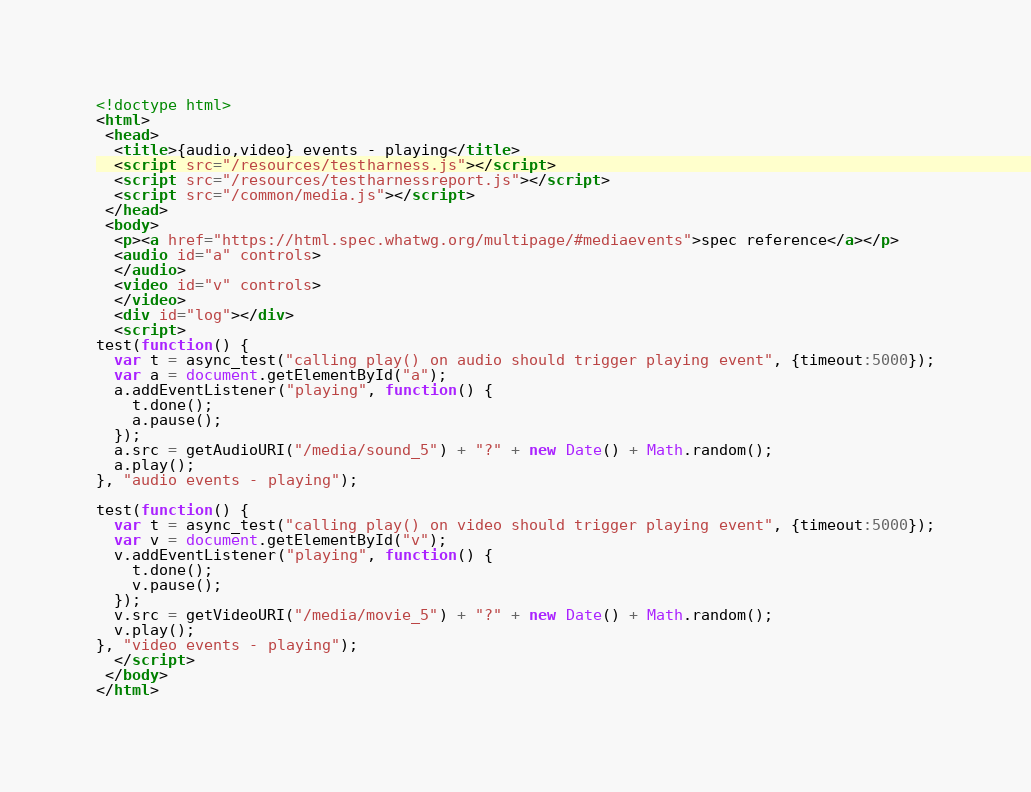Convert code to text. <code><loc_0><loc_0><loc_500><loc_500><_HTML_><!doctype html>
<html>
 <head>
  <title>{audio,video} events - playing</title>
  <script src="/resources/testharness.js"></script>
  <script src="/resources/testharnessreport.js"></script>
  <script src="/common/media.js"></script>
 </head>
 <body>
  <p><a href="https://html.spec.whatwg.org/multipage/#mediaevents">spec reference</a></p>
  <audio id="a" controls>
  </audio>
  <video id="v" controls>
  </video>
  <div id="log"></div>
  <script>
test(function() {
  var t = async_test("calling play() on audio should trigger playing event", {timeout:5000});
  var a = document.getElementById("a");
  a.addEventListener("playing", function() {
    t.done();
    a.pause();
  });
  a.src = getAudioURI("/media/sound_5") + "?" + new Date() + Math.random();
  a.play();
}, "audio events - playing");

test(function() {
  var t = async_test("calling play() on video should trigger playing event", {timeout:5000});
  var v = document.getElementById("v");
  v.addEventListener("playing", function() {
    t.done();
    v.pause();
  });
  v.src = getVideoURI("/media/movie_5") + "?" + new Date() + Math.random();
  v.play();
}, "video events - playing");
  </script>
 </body>
</html>
</code> 